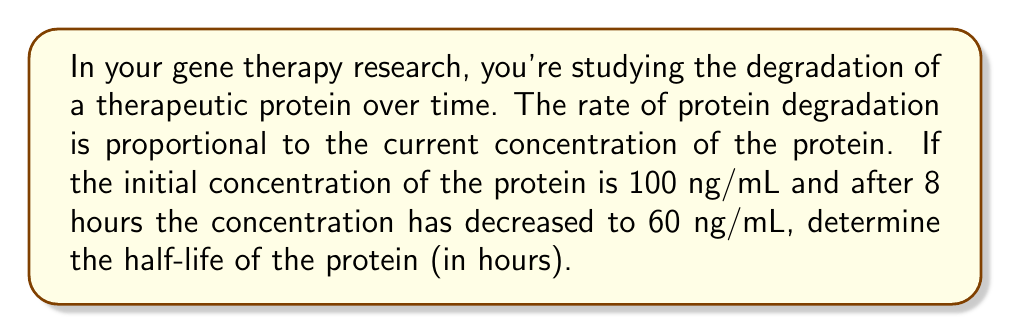Can you solve this math problem? Let's approach this step-by-step:

1) Let $P(t)$ be the protein concentration at time $t$ (in hours).

2) The rate of change of protein concentration is proportional to the current concentration:

   $$\frac{dP}{dt} = -kP$$

   where $k$ is the degradation rate constant.

3) This is a first-order differential equation. Its solution is:

   $$P(t) = P_0e^{-kt}$$

   where $P_0$ is the initial concentration.

4) We're given that $P_0 = 100$ ng/mL and $P(8) = 60$ ng/mL. Let's substitute these into our equation:

   $$60 = 100e^{-8k}$$

5) Solving for $k$:

   $$\frac{60}{100} = e^{-8k}$$
   $$0.6 = e^{-8k}$$
   $$\ln(0.6) = -8k$$
   $$k = -\frac{\ln(0.6)}{8} \approx 0.0639$$

6) The half-life $t_{1/2}$ is the time it takes for the concentration to decrease to half its initial value. It satisfies:

   $$\frac{1}{2} = e^{-kt_{1/2}}$$

7) Taking the natural log of both sides:

   $$\ln(\frac{1}{2}) = -kt_{1/2}$$
   $$t_{1/2} = -\frac{\ln(\frac{1}{2})}{k} = \frac{\ln(2)}{k}$$

8) Substituting our value for $k$:

   $$t_{1/2} = \frac{\ln(2)}{0.0639} \approx 10.85$$
Answer: The half-life of the protein is approximately 10.85 hours. 